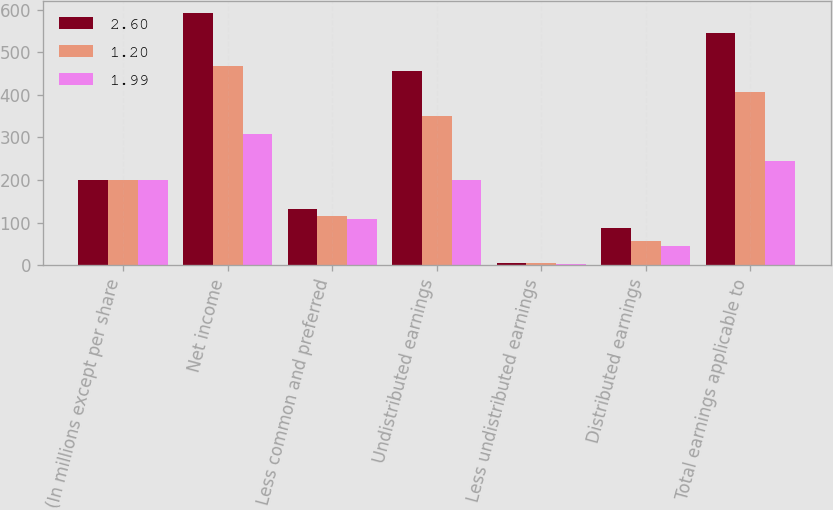Convert chart. <chart><loc_0><loc_0><loc_500><loc_500><stacked_bar_chart><ecel><fcel>(In millions except per share<fcel>Net income<fcel>Less common and preferred<fcel>Undistributed earnings<fcel>Less undistributed earnings<fcel>Distributed earnings<fcel>Total earnings applicable to<nl><fcel>2.6<fcel>201<fcel>592<fcel>131<fcel>457<fcel>4<fcel>88<fcel>545<nl><fcel>1.2<fcel>201<fcel>469<fcel>115<fcel>350<fcel>4<fcel>57<fcel>407<nl><fcel>1.99<fcel>201<fcel>309<fcel>108<fcel>199<fcel>2<fcel>45<fcel>244<nl></chart> 